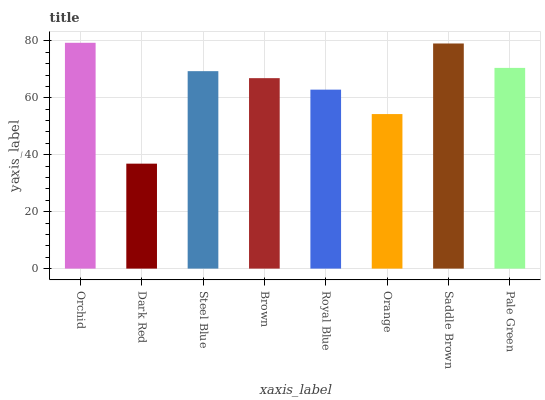Is Steel Blue the minimum?
Answer yes or no. No. Is Steel Blue the maximum?
Answer yes or no. No. Is Steel Blue greater than Dark Red?
Answer yes or no. Yes. Is Dark Red less than Steel Blue?
Answer yes or no. Yes. Is Dark Red greater than Steel Blue?
Answer yes or no. No. Is Steel Blue less than Dark Red?
Answer yes or no. No. Is Steel Blue the high median?
Answer yes or no. Yes. Is Brown the low median?
Answer yes or no. Yes. Is Royal Blue the high median?
Answer yes or no. No. Is Pale Green the low median?
Answer yes or no. No. 